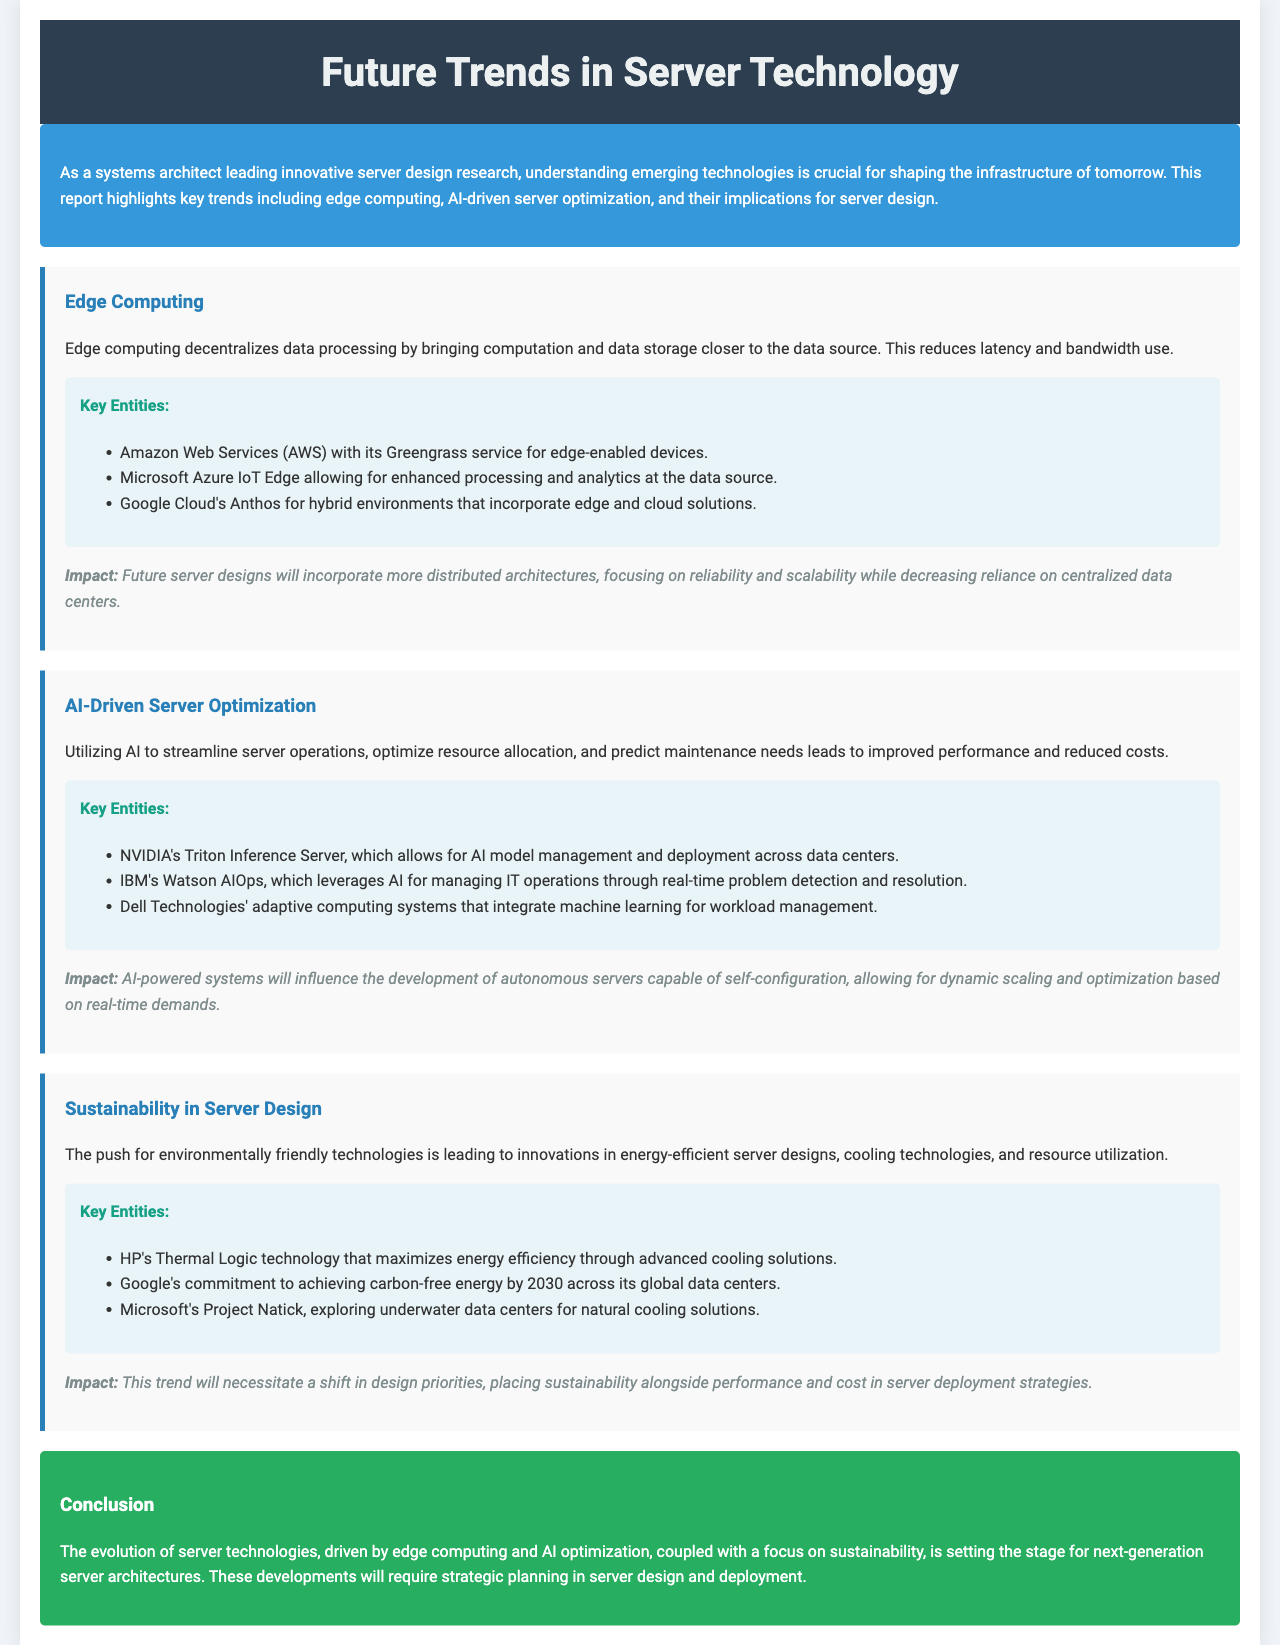What is the title of the report? The title is mentioned in the header of the document.
Answer: Future Trends in Server Technology What technology focuses on decentralizing data processing? "Edge Computing" is highlighted as a key trend.
Answer: Edge Computing Which company offers the Greengrass service? The company is listed under the "Key Entities" section in the edge computing trend.
Answer: Amazon Web Services (AWS) What will future server designs focus on according to edge computing? The impact section mentions the focus areas for future server designs.
Answer: Reliability and scalability What AI-driven technology does IBM provide for IT operations? This technology is mentioned in the "Key Entities" section under AI-driven server optimization.
Answer: Watson AIOps What is a key impact of AI-driven server optimization? The impact is discussed towards the end of the AI-driven server optimization trend.
Answer: Autonomous servers Which technology by HP maximizes energy efficiency? This technology is specified in the sustainability trend's key entities.
Answer: Thermal Logic What is the ultimate goal of Google's commitment regarding energy? This goal is stated in the key entities section related to sustainability.
Answer: Carbon-free energy by 2030 What does the conclusion suggest about next-generation server architectures? The conclusion summarizes the overarching theme of the report on server technology.
Answer: Strategic planning in server design and deployment 